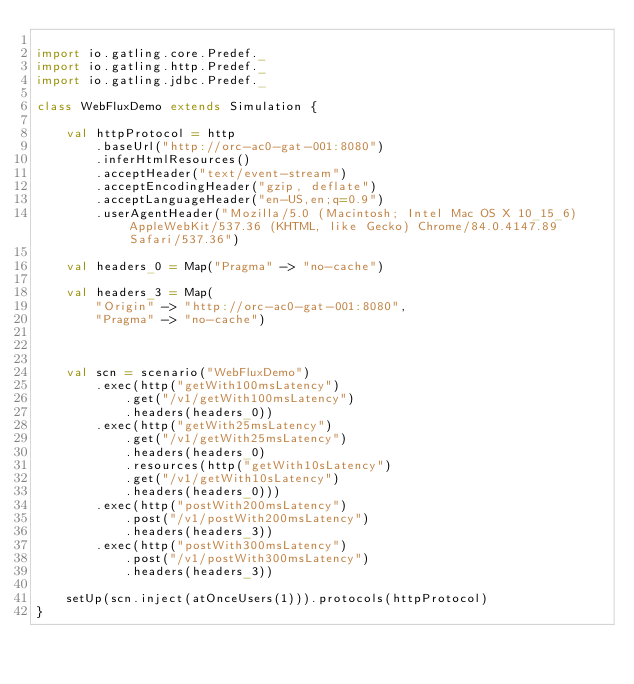<code> <loc_0><loc_0><loc_500><loc_500><_Scala_>
import io.gatling.core.Predef._
import io.gatling.http.Predef._
import io.gatling.jdbc.Predef._

class WebFluxDemo extends Simulation {

	val httpProtocol = http
		.baseUrl("http://orc-ac0-gat-001:8080")
		.inferHtmlResources()
		.acceptHeader("text/event-stream")
		.acceptEncodingHeader("gzip, deflate")
		.acceptLanguageHeader("en-US,en;q=0.9")
		.userAgentHeader("Mozilla/5.0 (Macintosh; Intel Mac OS X 10_15_6) AppleWebKit/537.36 (KHTML, like Gecko) Chrome/84.0.4147.89 Safari/537.36")

	val headers_0 = Map("Pragma" -> "no-cache")

	val headers_3 = Map(
		"Origin" -> "http://orc-ac0-gat-001:8080",
		"Pragma" -> "no-cache")



	val scn = scenario("WebFluxDemo")
		.exec(http("getWith100msLatency")
			.get("/v1/getWith100msLatency")
			.headers(headers_0))
		.exec(http("getWith25msLatency")
			.get("/v1/getWith25msLatency")
			.headers(headers_0)
			.resources(http("getWith10sLatency")
			.get("/v1/getWith10sLatency")
			.headers(headers_0)))
		.exec(http("postWith200msLatency")
			.post("/v1/postWith200msLatency")
			.headers(headers_3))
		.exec(http("postWith300msLatency")
			.post("/v1/postWith300msLatency")
			.headers(headers_3))

	setUp(scn.inject(atOnceUsers(1))).protocols(httpProtocol)
}</code> 